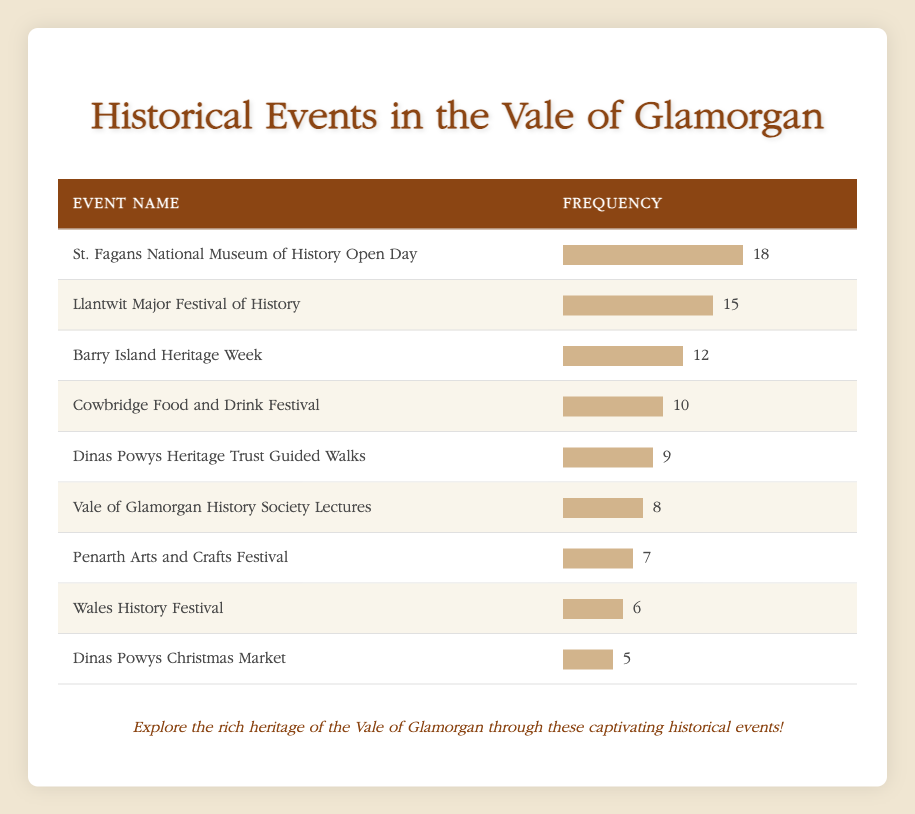What is the most frequently celebrated historical event in the Vale of Glamorgan? The table shows various historical events along with their frequencies. The highest frequency is 18, associated with the event "St. Fagans National Museum of History Open Day."
Answer: St. Fagans National Museum of History Open Day How many events have a frequency of 10 or more? By checking the frequencies listed, the events with a frequency of 10 or more are: "St. Fagans National Museum of History Open Day" (18), "Llantwit Major Festival of History" (15), "Barry Island Heritage Week" (12), and "Cowbridge Food and Drink Festival" (10). This totals to 4 events.
Answer: 4 What is the frequency of the "Dinas Powys Christmas Market"? The table lists "Dinas Powys Christmas Market" with a frequency of 5.
Answer: 5 Is the "Penarth Arts and Crafts Festival" more frequent than the "Vale of Glamorgan History Society Lectures"? The frequency of "Penarth Arts and Crafts Festival" is 7 and for "Vale of Glamorgan History Society Lectures" it is 8. Since 7 is not greater than 8, the statement is false.
Answer: No What is the sum of the frequencies of "Wales History Festival" and "Dinas Powys Christmas Market"? The frequency of "Wales History Festival" is 6 and for "Dinas Powys Christmas Market" it is 5. Adding these together gives 6 + 5 = 11.
Answer: 11 Which event has the least frequency? Observing the frequencies, "Dinas Powys Christmas Market" has the least frequency with a value of 5.
Answer: Dinas Powys Christmas Market What is the average frequency of all the events listed? The total frequency of all events is 18 + 15 + 12 + 10 + 9 + 8 + 7 + 6 + 5 = 90. There are 9 events, so the average frequency is 90 / 9 = 10.
Answer: 10 Is "Barry Island Heritage Week" celebrated more frequently than "Cowbridge Food and Drink Festival"? The frequency of "Barry Island Heritage Week" is 12 and for "Cowbridge Food and Drink Festival" it is 10. Since 12 is greater than 10, the statement is true.
Answer: Yes What is the frequency difference between the "Llantwit Major Festival of History" and the "Vale of Glamorgan History Society Lectures"? The frequency of "Llantwit Major Festival of History" is 15 and for "Vale of Glamorgan History Society Lectures," it is 8. The difference is 15 - 8 = 7.
Answer: 7 